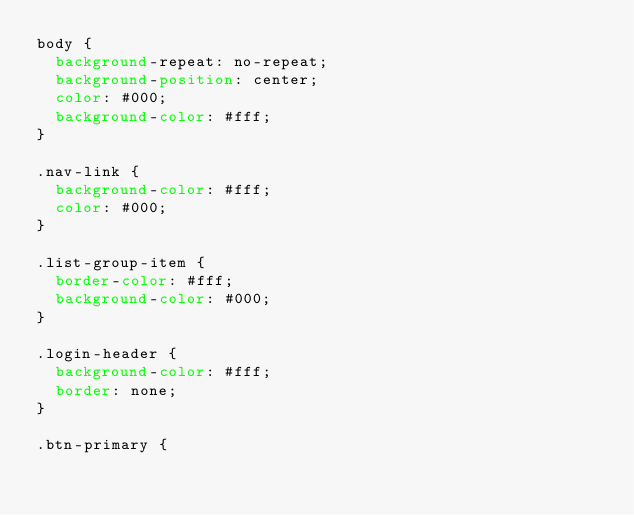<code> <loc_0><loc_0><loc_500><loc_500><_CSS_>body {
  background-repeat: no-repeat;
  background-position: center;
  color: #000;
  background-color: #fff;
}

.nav-link {
  background-color: #fff;
  color: #000;
}

.list-group-item {
  border-color: #fff;
  background-color: #000;
}

.login-header {
  background-color: #fff;
  border: none;
}

.btn-primary {</code> 